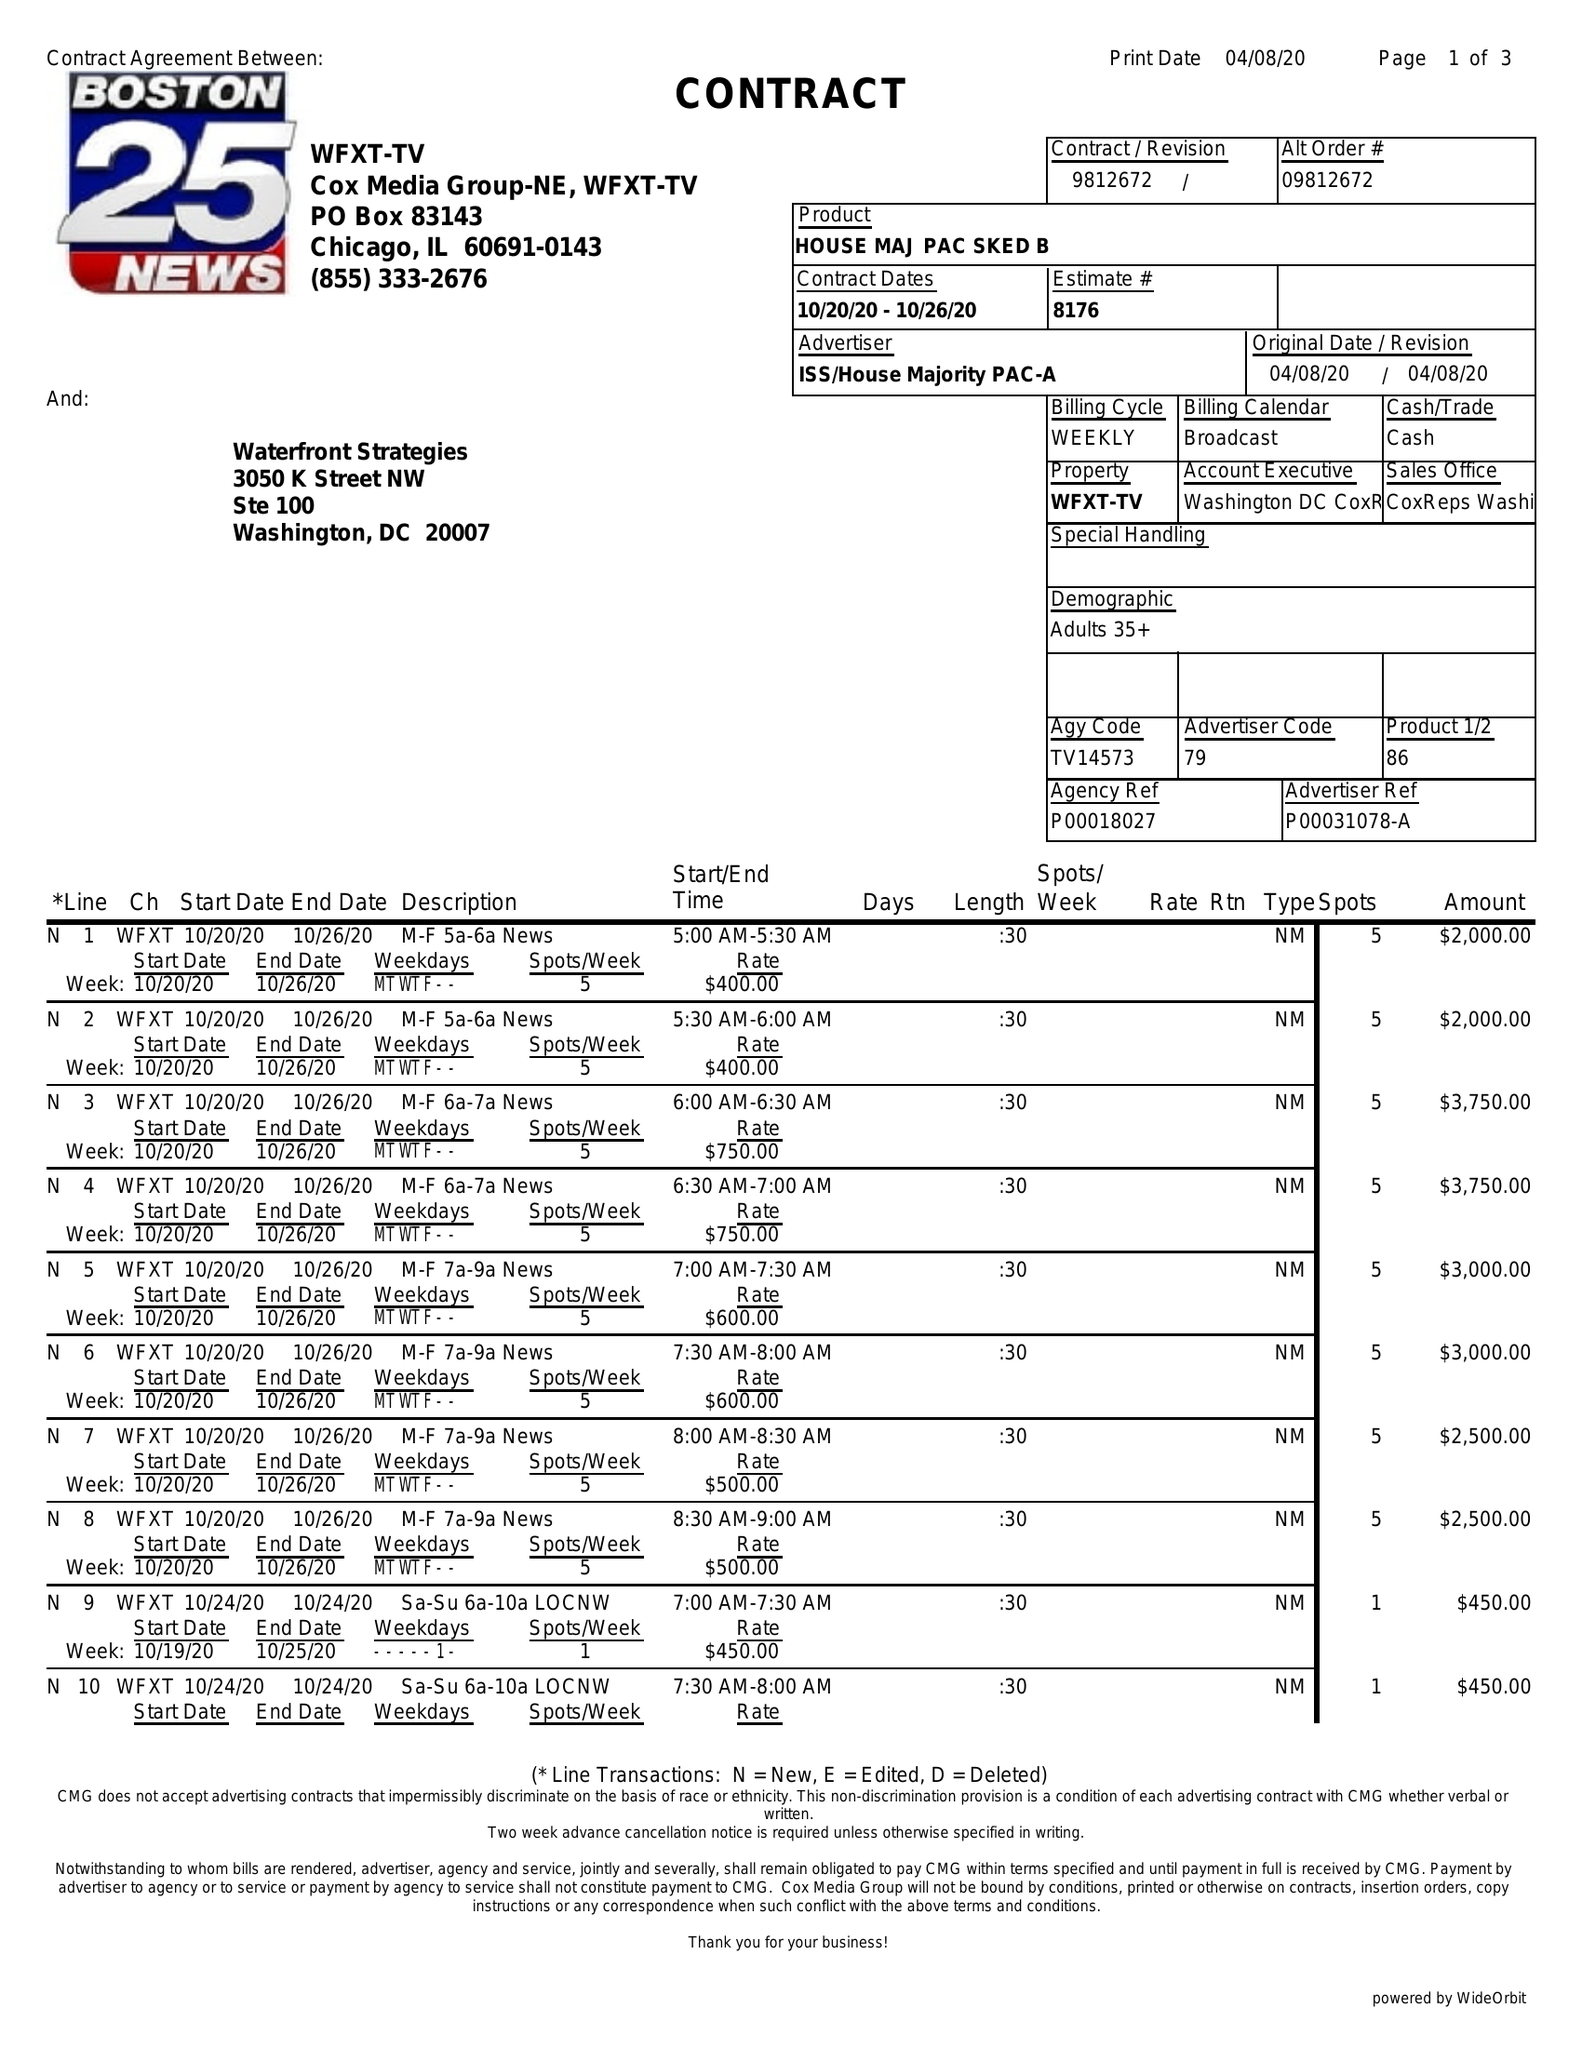What is the value for the contract_num?
Answer the question using a single word or phrase. 9812672 